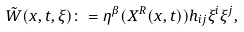Convert formula to latex. <formula><loc_0><loc_0><loc_500><loc_500>\tilde { W } ( x , t , \xi ) \colon = \eta ^ { \beta } ( X ^ { R } ( x , t ) ) h _ { i j } \xi ^ { i } \xi ^ { j } ,</formula> 